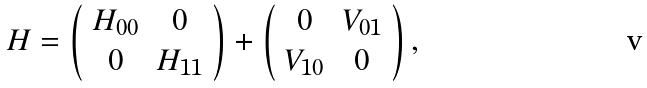Convert formula to latex. <formula><loc_0><loc_0><loc_500><loc_500>H = \left ( \begin{array} { c c } H _ { 0 0 } & 0 \\ 0 & H _ { 1 1 } \end{array} \right ) + \left ( \begin{array} { c c } 0 & V _ { 0 1 } \\ V _ { 1 0 } & 0 \end{array} \right ) ,</formula> 